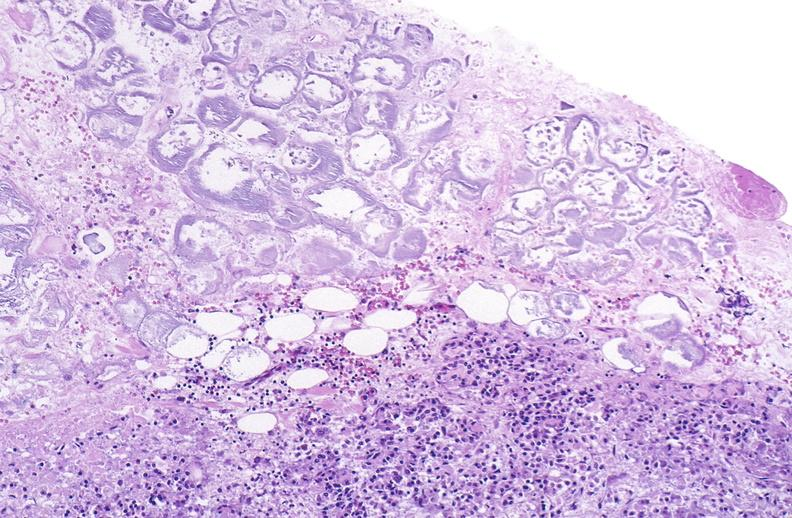what does this image show?
Answer the question using a single word or phrase. Pancreatic fat necrosis 